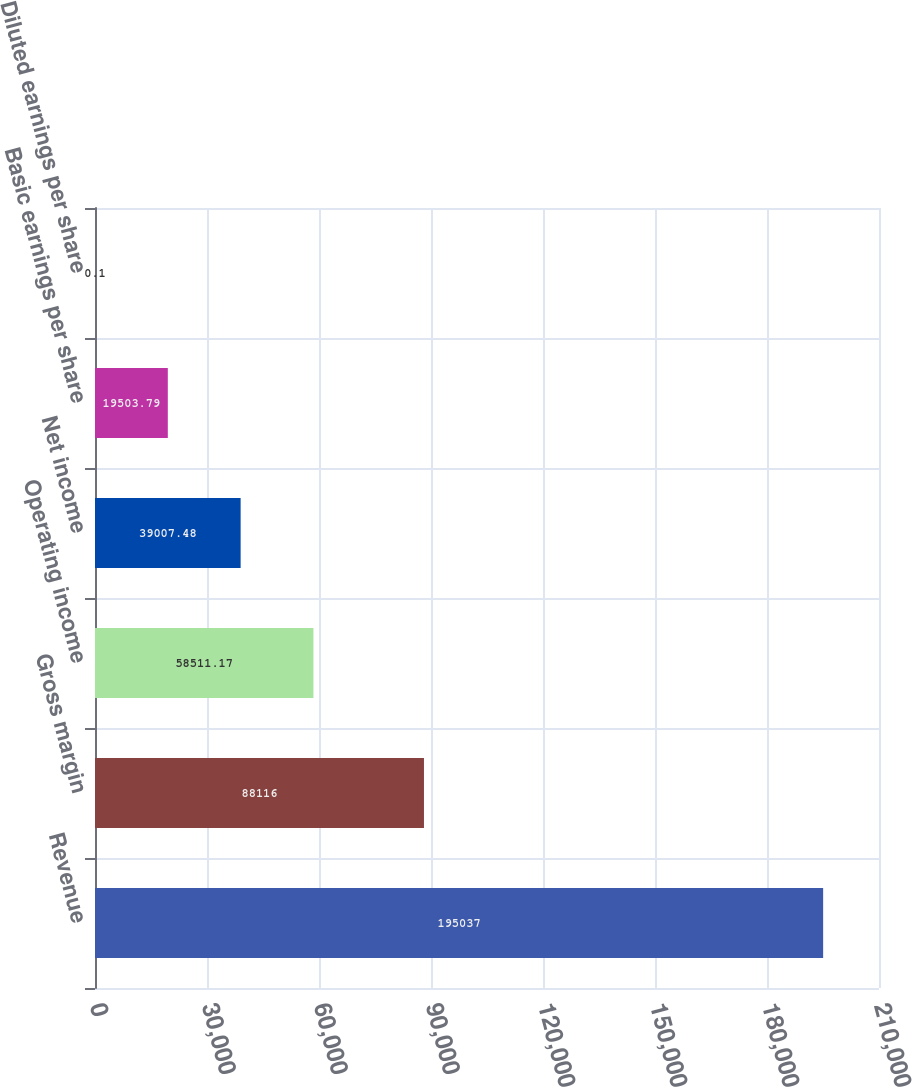Convert chart to OTSL. <chart><loc_0><loc_0><loc_500><loc_500><bar_chart><fcel>Revenue<fcel>Gross margin<fcel>Operating income<fcel>Net income<fcel>Basic earnings per share<fcel>Diluted earnings per share<nl><fcel>195037<fcel>88116<fcel>58511.2<fcel>39007.5<fcel>19503.8<fcel>0.1<nl></chart> 